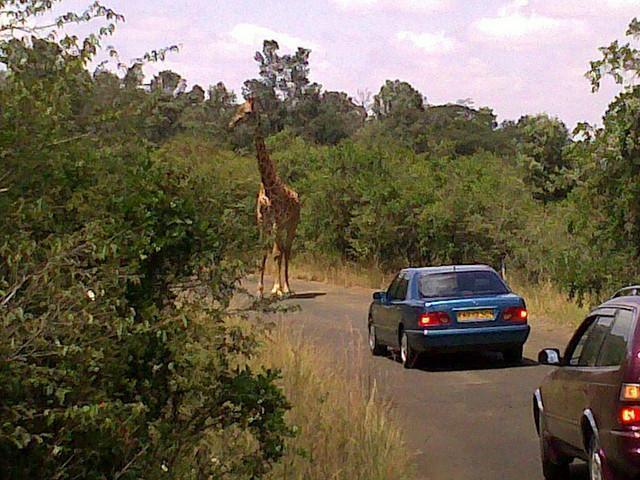What are you supposed to do when you meet an animal like this on the road?
Indicate the correct response by choosing from the four available options to answer the question.
Options: Stop, reverse, go, hoot. Stop. 